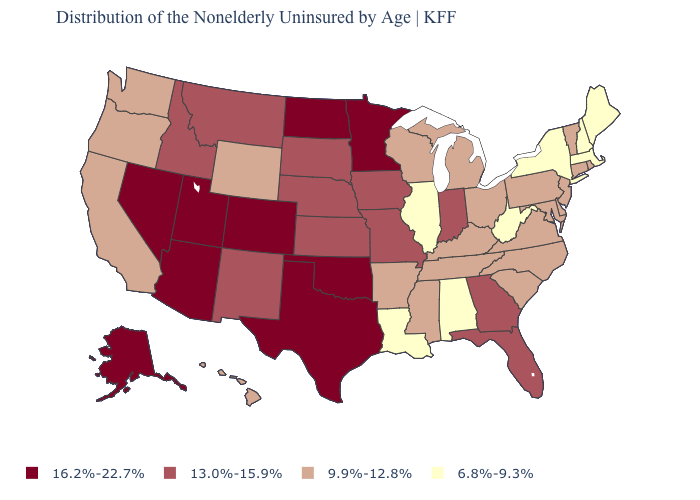Which states hav the highest value in the South?
Give a very brief answer. Oklahoma, Texas. What is the value of California?
Short answer required. 9.9%-12.8%. What is the value of Nebraska?
Answer briefly. 13.0%-15.9%. What is the value of New Mexico?
Quick response, please. 13.0%-15.9%. Name the states that have a value in the range 13.0%-15.9%?
Be succinct. Florida, Georgia, Idaho, Indiana, Iowa, Kansas, Missouri, Montana, Nebraska, New Mexico, South Dakota. Does Vermont have a higher value than Alaska?
Concise answer only. No. Among the states that border Arkansas , which have the highest value?
Give a very brief answer. Oklahoma, Texas. Which states hav the highest value in the South?
Write a very short answer. Oklahoma, Texas. Among the states that border North Carolina , does Virginia have the highest value?
Be succinct. No. Does Rhode Island have a higher value than Iowa?
Keep it brief. No. Does the map have missing data?
Write a very short answer. No. Among the states that border Idaho , which have the highest value?
Be succinct. Nevada, Utah. What is the value of Illinois?
Write a very short answer. 6.8%-9.3%. Name the states that have a value in the range 6.8%-9.3%?
Keep it brief. Alabama, Illinois, Louisiana, Maine, Massachusetts, New Hampshire, New York, West Virginia. Name the states that have a value in the range 6.8%-9.3%?
Keep it brief. Alabama, Illinois, Louisiana, Maine, Massachusetts, New Hampshire, New York, West Virginia. 